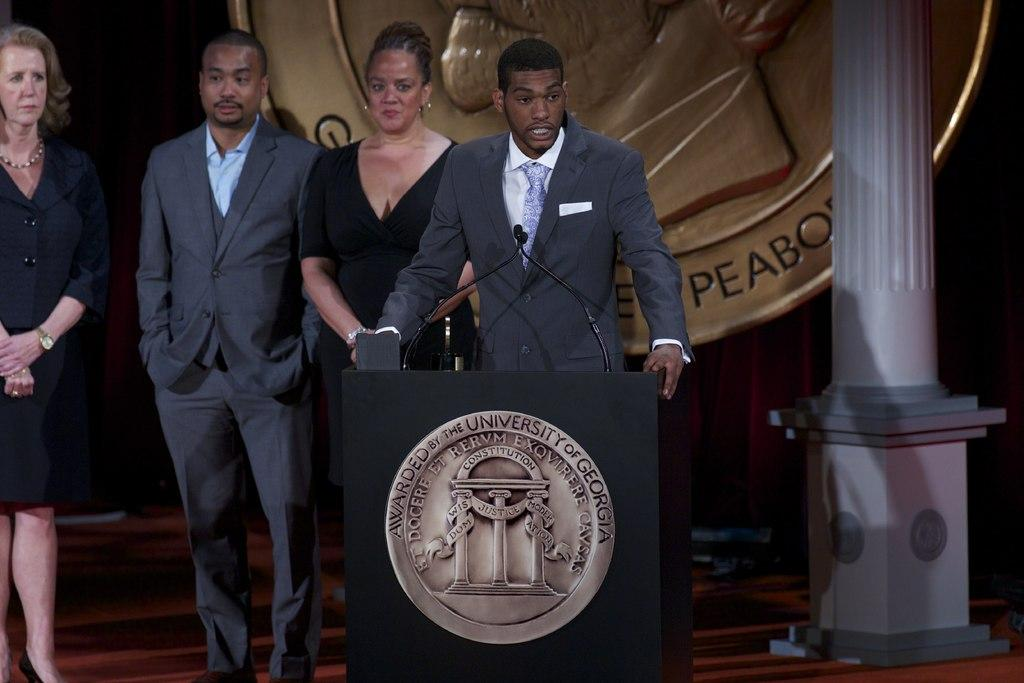<image>
Summarize the visual content of the image. A man speaks from behind a podium that says Awarded by the University of Georgia on it. 